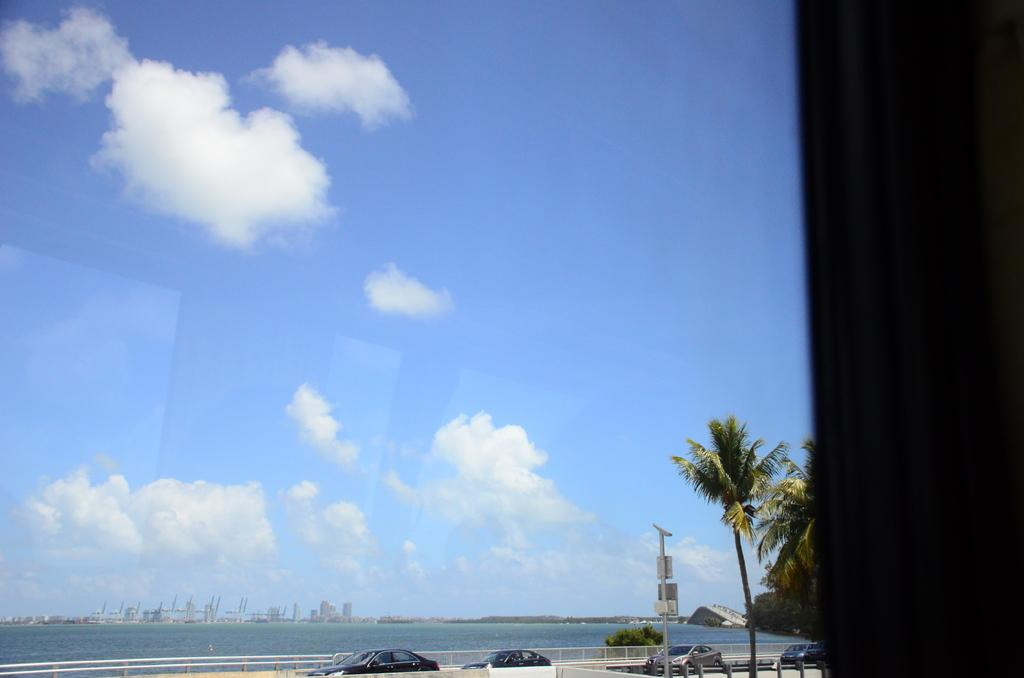What type of structures can be seen in the image? There are buildings in the image. What else is present in the image besides buildings? There are vehicles, a barrier, trees, and the sea visible in the image. Can you describe the weather in the image? The sky is cloudy and pale blue in the image. What type of celery can be seen growing near the vehicles in the image? There is no celery present in the image; it features buildings, vehicles, a barrier, trees, the sea, and a cloudy, pale blue sky. How many balls are visible in the image? There are no balls present in the image. 